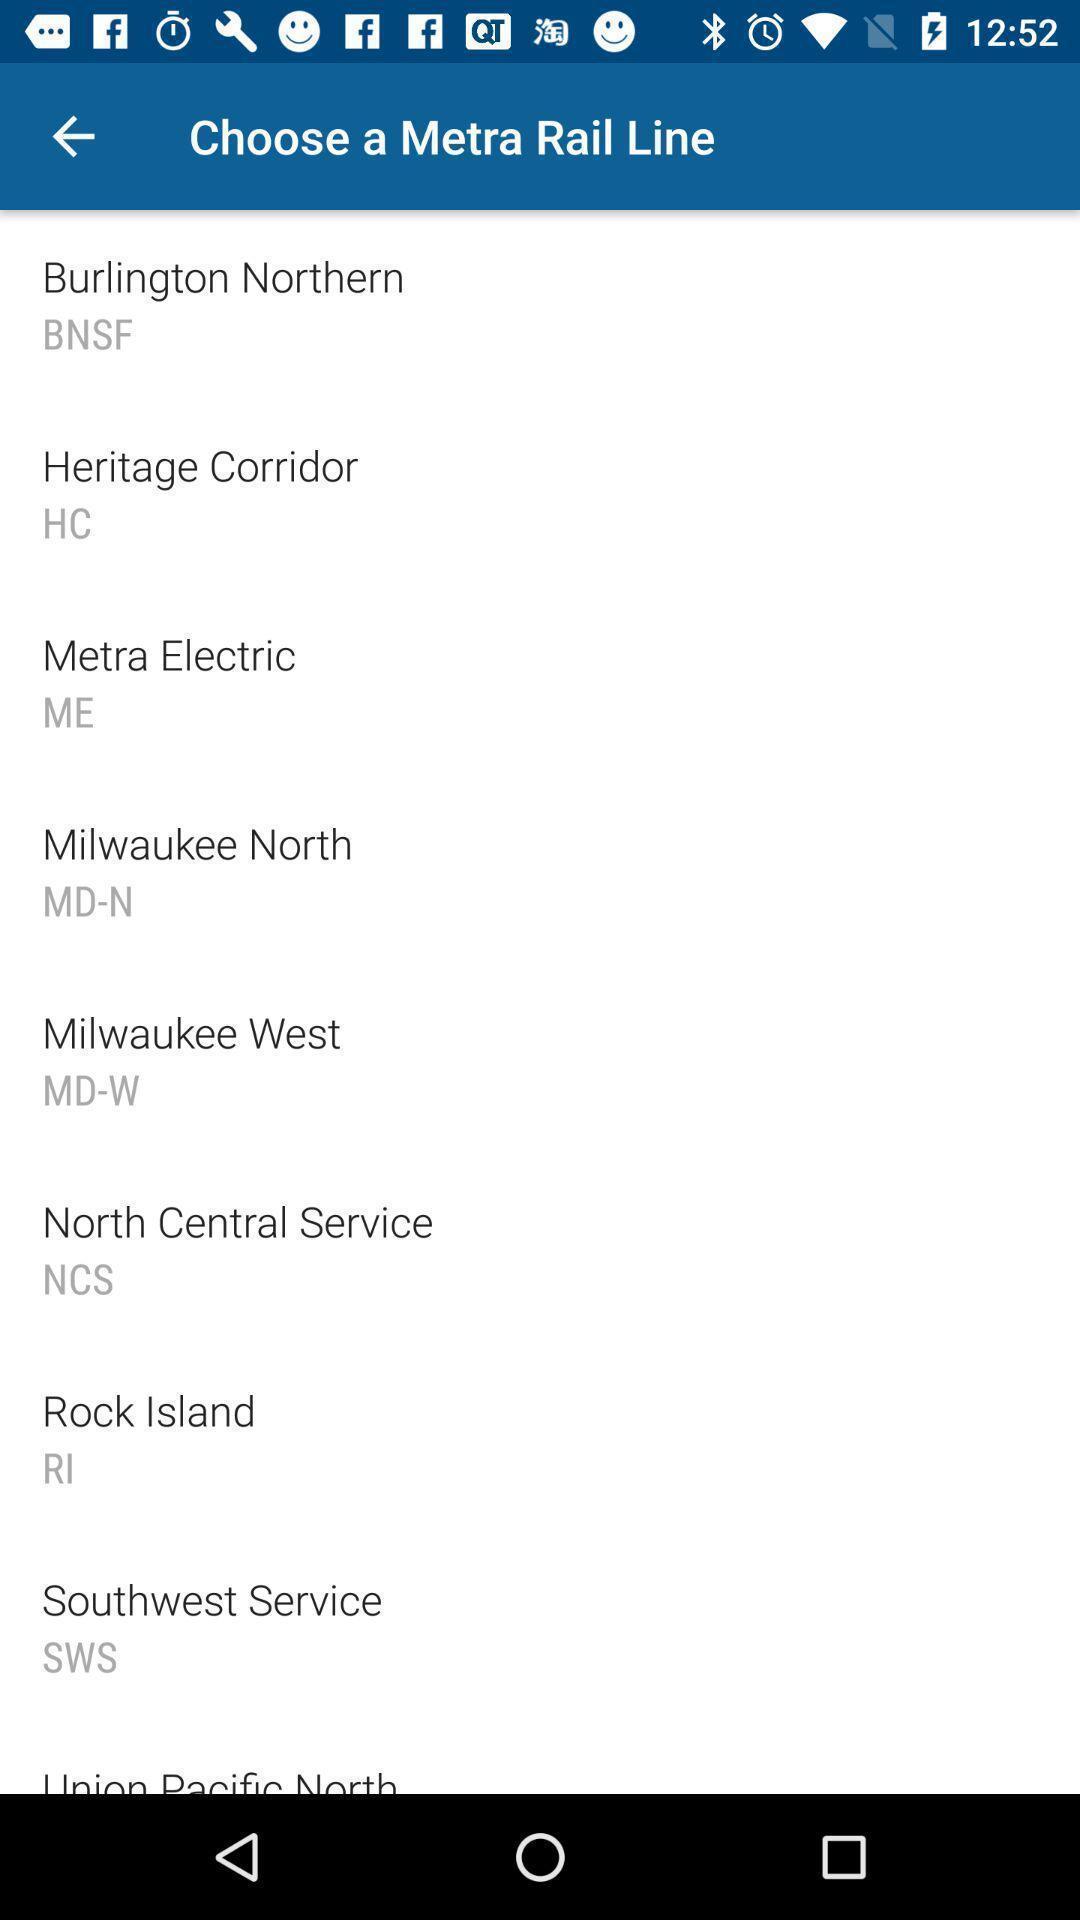Summarize the information in this screenshot. Page showing rail lines on a travel app. 